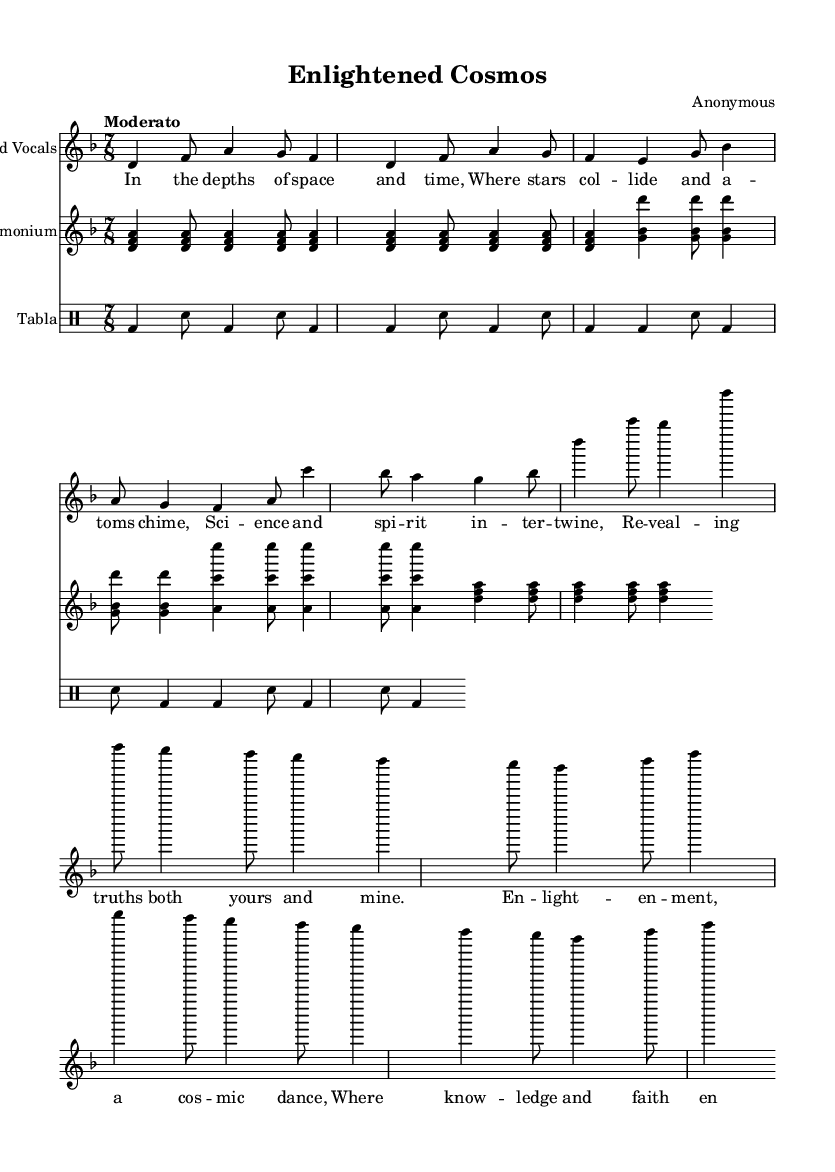What is the key signature of this music? The key signature is reflected in the first part of the global context where "d" indicates D minor. The absence of any sharps or flats shows the tonality in D minor.
Answer: D minor What is the time signature of the piece? The time signature is indicated alongside the key signature in the global context, marked as "7/8," which shows that each measure contains seven eighth notes.
Answer: 7/8 What is the tempo indication provided? The tempo is listed in the global section of the music as "Moderato," which describes the speed of the performance.
Answer: Moderato How many measures are there in the lead vocals section? By counting the measures in the lead vocals section where the music notation is provided, we can see there are eight measures total.
Answer: Eight What two thematic elements are intertwined in the lyrics? The lyrics refer to "science" and "spirit" in the first verse, showing a connection between these two themes of enlightenment.
Answer: Science and spirit What type of instrumentation is used in this piece? The score includes a lead vocals part, harmonium, and tabla, indicating a typical Sufi qawwali ensemble that reflects both vocal and instrumental performances.
Answer: Harmonium and tabla 